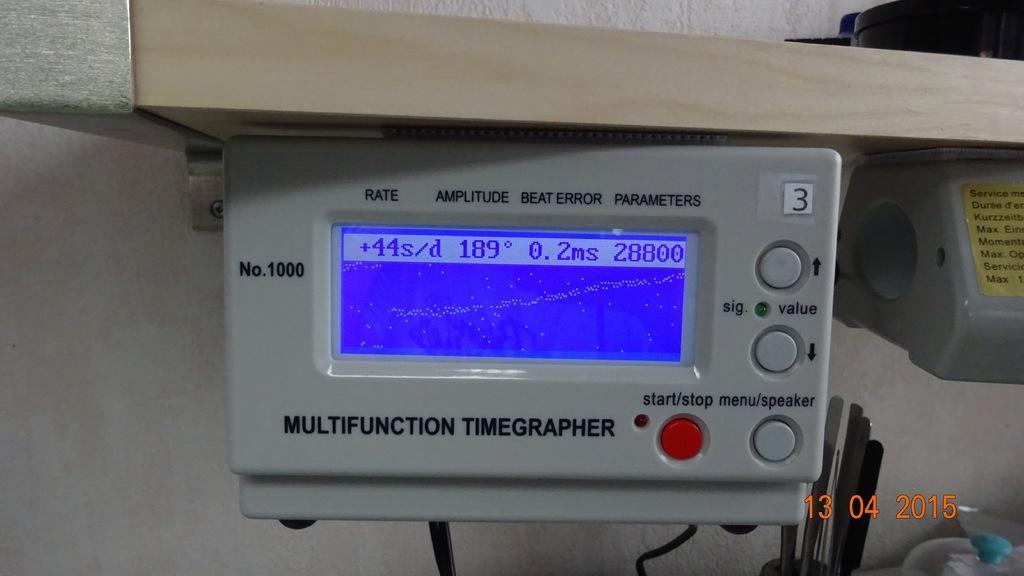Please provide a concise description of this image. In this image there is a machine, on that there is a display and buttons, in the bottom right there is date. 